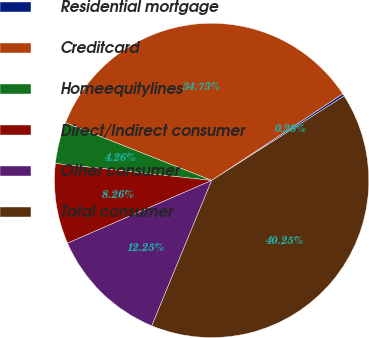<chart> <loc_0><loc_0><loc_500><loc_500><pie_chart><fcel>Residential mortgage<fcel>Creditcard<fcel>Homeequitylines<fcel>Direct/Indirect consumer<fcel>Other consumer<fcel>Total consumer<nl><fcel>0.26%<fcel>34.73%<fcel>4.26%<fcel>8.26%<fcel>12.25%<fcel>40.25%<nl></chart> 